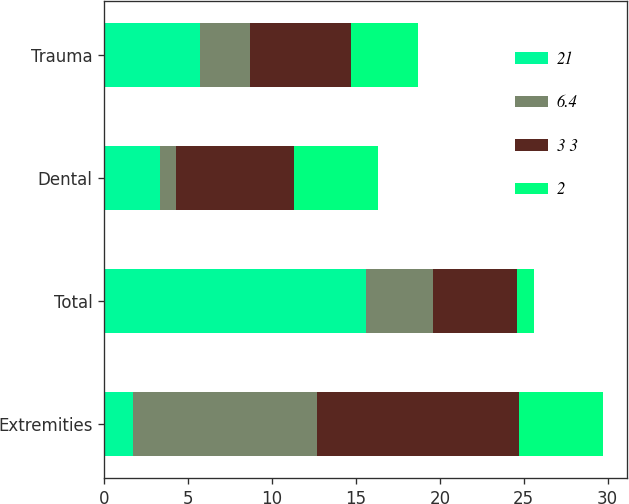Convert chart to OTSL. <chart><loc_0><loc_0><loc_500><loc_500><stacked_bar_chart><ecel><fcel>Extremities<fcel>Total<fcel>Dental<fcel>Trauma<nl><fcel>21<fcel>1.7<fcel>15.6<fcel>3.3<fcel>5.7<nl><fcel>6.4<fcel>11<fcel>4<fcel>1<fcel>3<nl><fcel>3 3<fcel>12<fcel>5<fcel>7<fcel>6<nl><fcel>2<fcel>5<fcel>1<fcel>5<fcel>4<nl></chart> 